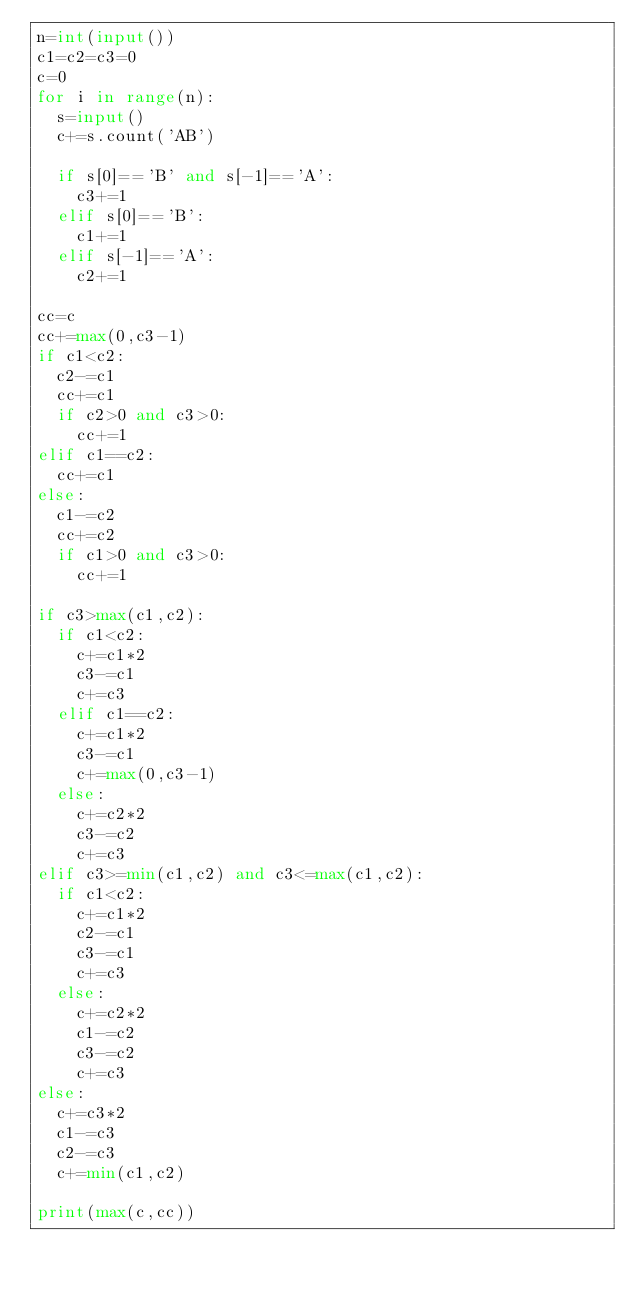Convert code to text. <code><loc_0><loc_0><loc_500><loc_500><_Python_>n=int(input())
c1=c2=c3=0
c=0
for i in range(n):
  s=input()
  c+=s.count('AB')

  if s[0]=='B' and s[-1]=='A':
    c3+=1
  elif s[0]=='B':
    c1+=1
  elif s[-1]=='A':
    c2+=1

cc=c
cc+=max(0,c3-1)
if c1<c2:
  c2-=c1
  cc+=c1
  if c2>0 and c3>0:
    cc+=1
elif c1==c2:
  cc+=c1
else:
  c1-=c2
  cc+=c2
  if c1>0 and c3>0:
    cc+=1

if c3>max(c1,c2):
  if c1<c2:
    c+=c1*2
    c3-=c1
    c+=c3
  elif c1==c2:
    c+=c1*2
    c3-=c1
    c+=max(0,c3-1)
  else:
    c+=c2*2
    c3-=c2
    c+=c3
elif c3>=min(c1,c2) and c3<=max(c1,c2):
  if c1<c2:
    c+=c1*2
    c2-=c1
    c3-=c1
    c+=c3
  else:
    c+=c2*2
    c1-=c2
    c3-=c2
    c+=c3
else:
  c+=c3*2
  c1-=c3
  c2-=c3
  c+=min(c1,c2)

print(max(c,cc))</code> 